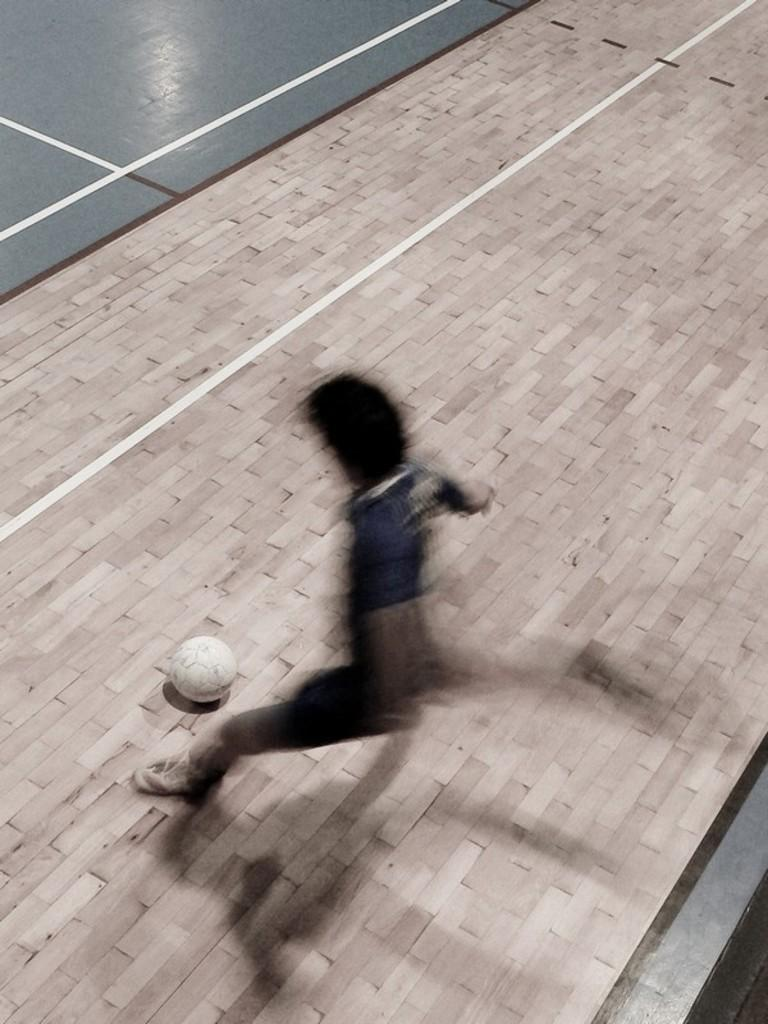What is the main subject of the image? There is a blurry person in the image. What object is visible near the person? There is a white color football in the image. What can be seen on the floor in the image? There are lines on the floor in the image. How does the person in the image support the team with their cough? There is no mention of a cough or team support in the image, as it only features a blurry person and a white color football on the floor. 